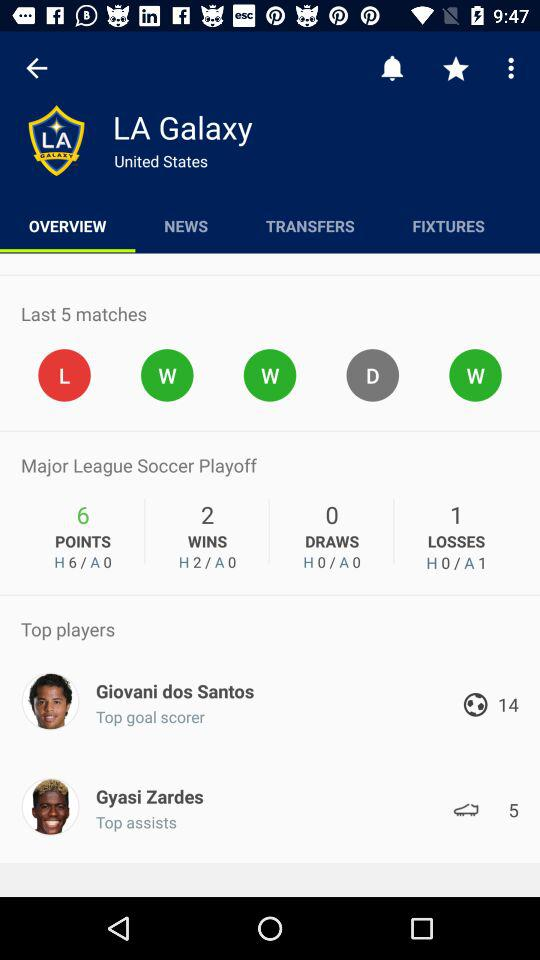How many goals has Giovani dos Santos scored? Based on the image, Giovani dos Santos is listed as the top goal scorer with a total of 14 goals. This statistic highlights his skill as a forward and shows his important contribution to his team's offensive power. 